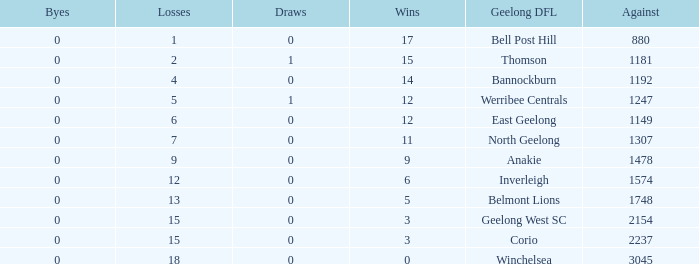What is the lowest number of wins where the byes are less than 0? None. 